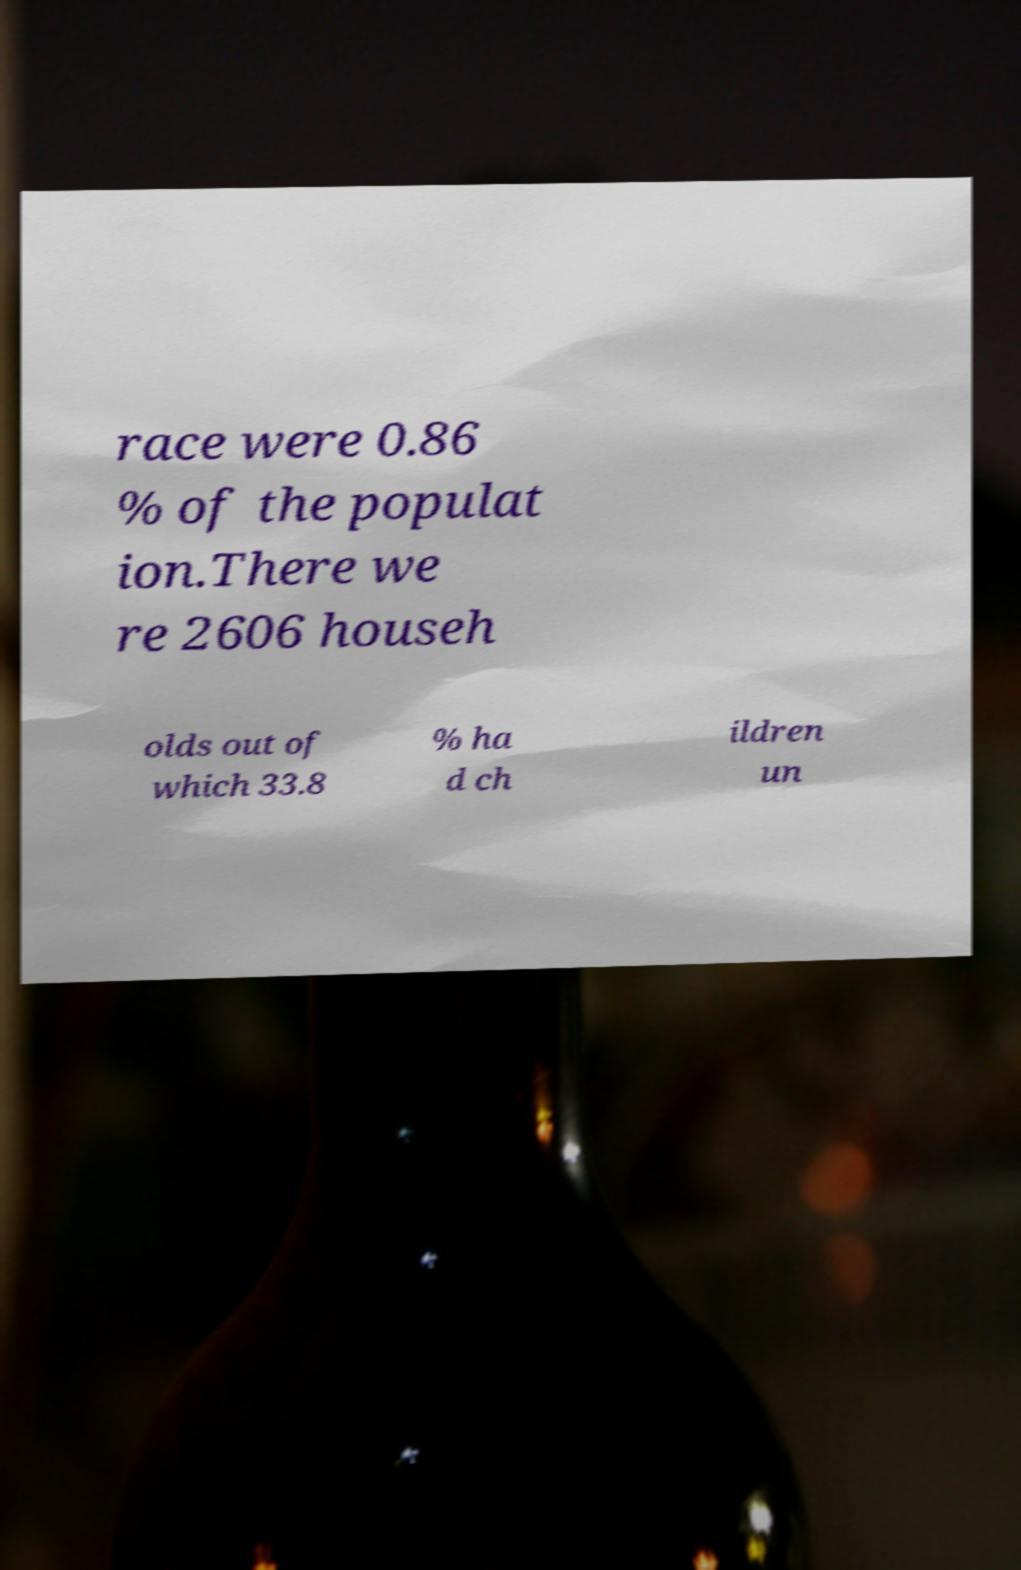Could you extract and type out the text from this image? race were 0.86 % of the populat ion.There we re 2606 househ olds out of which 33.8 % ha d ch ildren un 